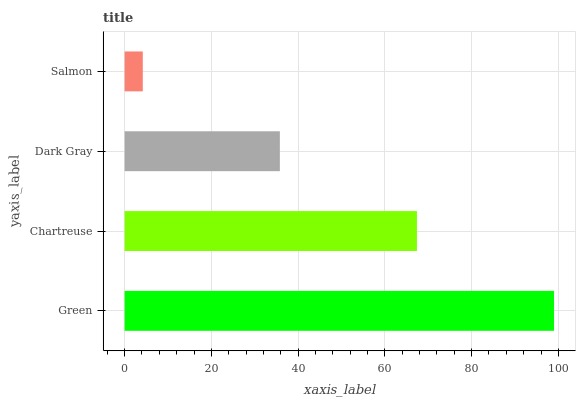Is Salmon the minimum?
Answer yes or no. Yes. Is Green the maximum?
Answer yes or no. Yes. Is Chartreuse the minimum?
Answer yes or no. No. Is Chartreuse the maximum?
Answer yes or no. No. Is Green greater than Chartreuse?
Answer yes or no. Yes. Is Chartreuse less than Green?
Answer yes or no. Yes. Is Chartreuse greater than Green?
Answer yes or no. No. Is Green less than Chartreuse?
Answer yes or no. No. Is Chartreuse the high median?
Answer yes or no. Yes. Is Dark Gray the low median?
Answer yes or no. Yes. Is Dark Gray the high median?
Answer yes or no. No. Is Green the low median?
Answer yes or no. No. 